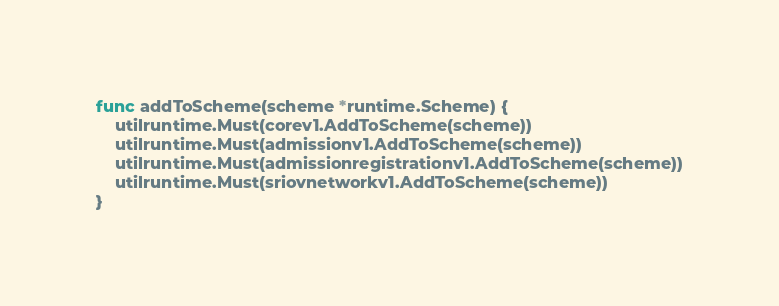<code> <loc_0><loc_0><loc_500><loc_500><_Go_>func addToScheme(scheme *runtime.Scheme) {
	utilruntime.Must(corev1.AddToScheme(scheme))
	utilruntime.Must(admissionv1.AddToScheme(scheme))
	utilruntime.Must(admissionregistrationv1.AddToScheme(scheme))
	utilruntime.Must(sriovnetworkv1.AddToScheme(scheme))
}
</code> 